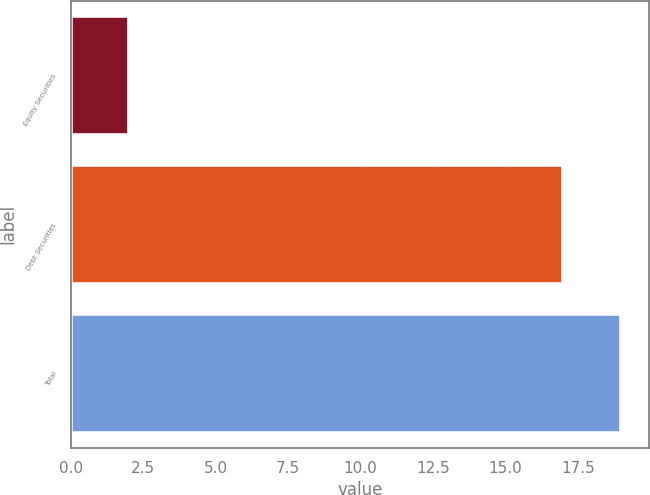Convert chart. <chart><loc_0><loc_0><loc_500><loc_500><bar_chart><fcel>Equity Securities<fcel>Debt Securities<fcel>Total<nl><fcel>2<fcel>17<fcel>19<nl></chart> 